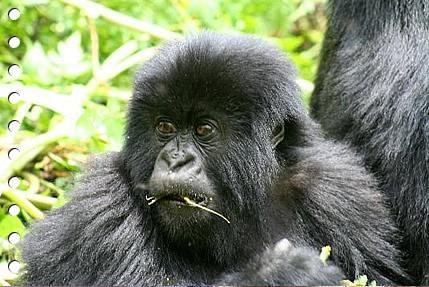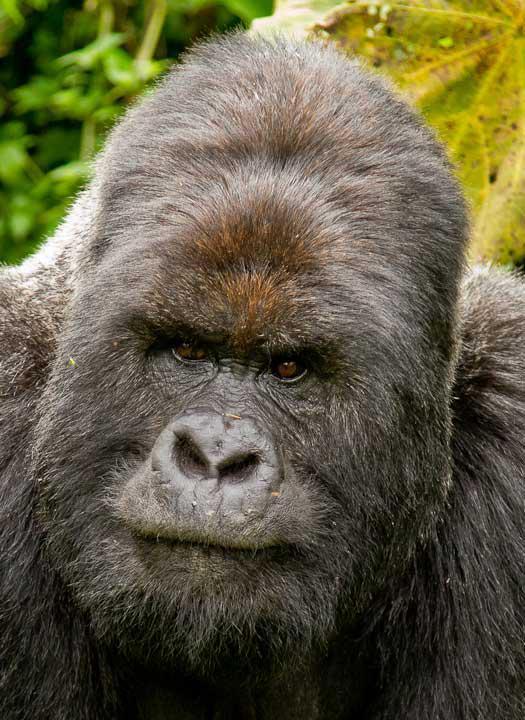The first image is the image on the left, the second image is the image on the right. For the images displayed, is the sentence "In at least one image there are two gorilla one adult holding a single baby." factually correct? Answer yes or no. No. The first image is the image on the left, the second image is the image on the right. Examine the images to the left and right. Is the description "There are exactly three gorillas." accurate? Answer yes or no. No. 